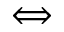Convert formula to latex. <formula><loc_0><loc_0><loc_500><loc_500>\Longleftrightarrow</formula> 